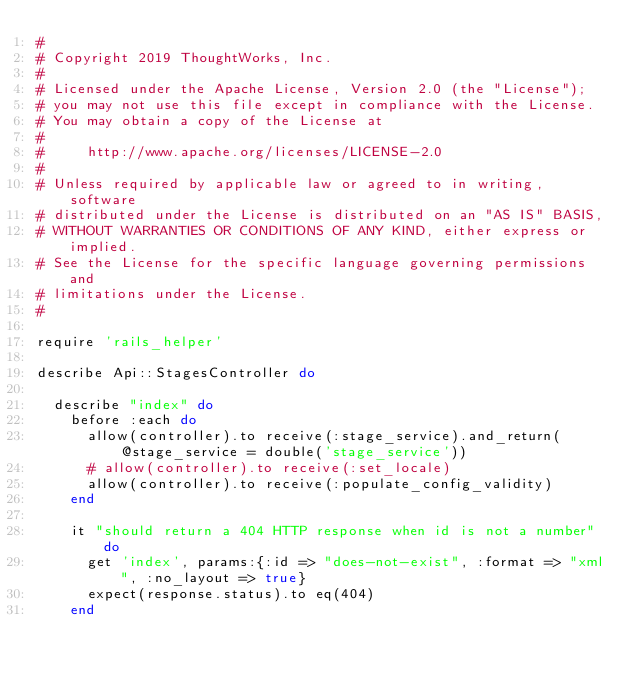Convert code to text. <code><loc_0><loc_0><loc_500><loc_500><_Ruby_>#
# Copyright 2019 ThoughtWorks, Inc.
#
# Licensed under the Apache License, Version 2.0 (the "License");
# you may not use this file except in compliance with the License.
# You may obtain a copy of the License at
#
#     http://www.apache.org/licenses/LICENSE-2.0
#
# Unless required by applicable law or agreed to in writing, software
# distributed under the License is distributed on an "AS IS" BASIS,
# WITHOUT WARRANTIES OR CONDITIONS OF ANY KIND, either express or implied.
# See the License for the specific language governing permissions and
# limitations under the License.
#

require 'rails_helper'

describe Api::StagesController do

  describe "index" do
    before :each do
      allow(controller).to receive(:stage_service).and_return(@stage_service = double('stage_service'))
      # allow(controller).to receive(:set_locale)
      allow(controller).to receive(:populate_config_validity)
    end

    it "should return a 404 HTTP response when id is not a number" do
      get 'index', params:{:id => "does-not-exist", :format => "xml", :no_layout => true}
      expect(response.status).to eq(404)
    end
</code> 